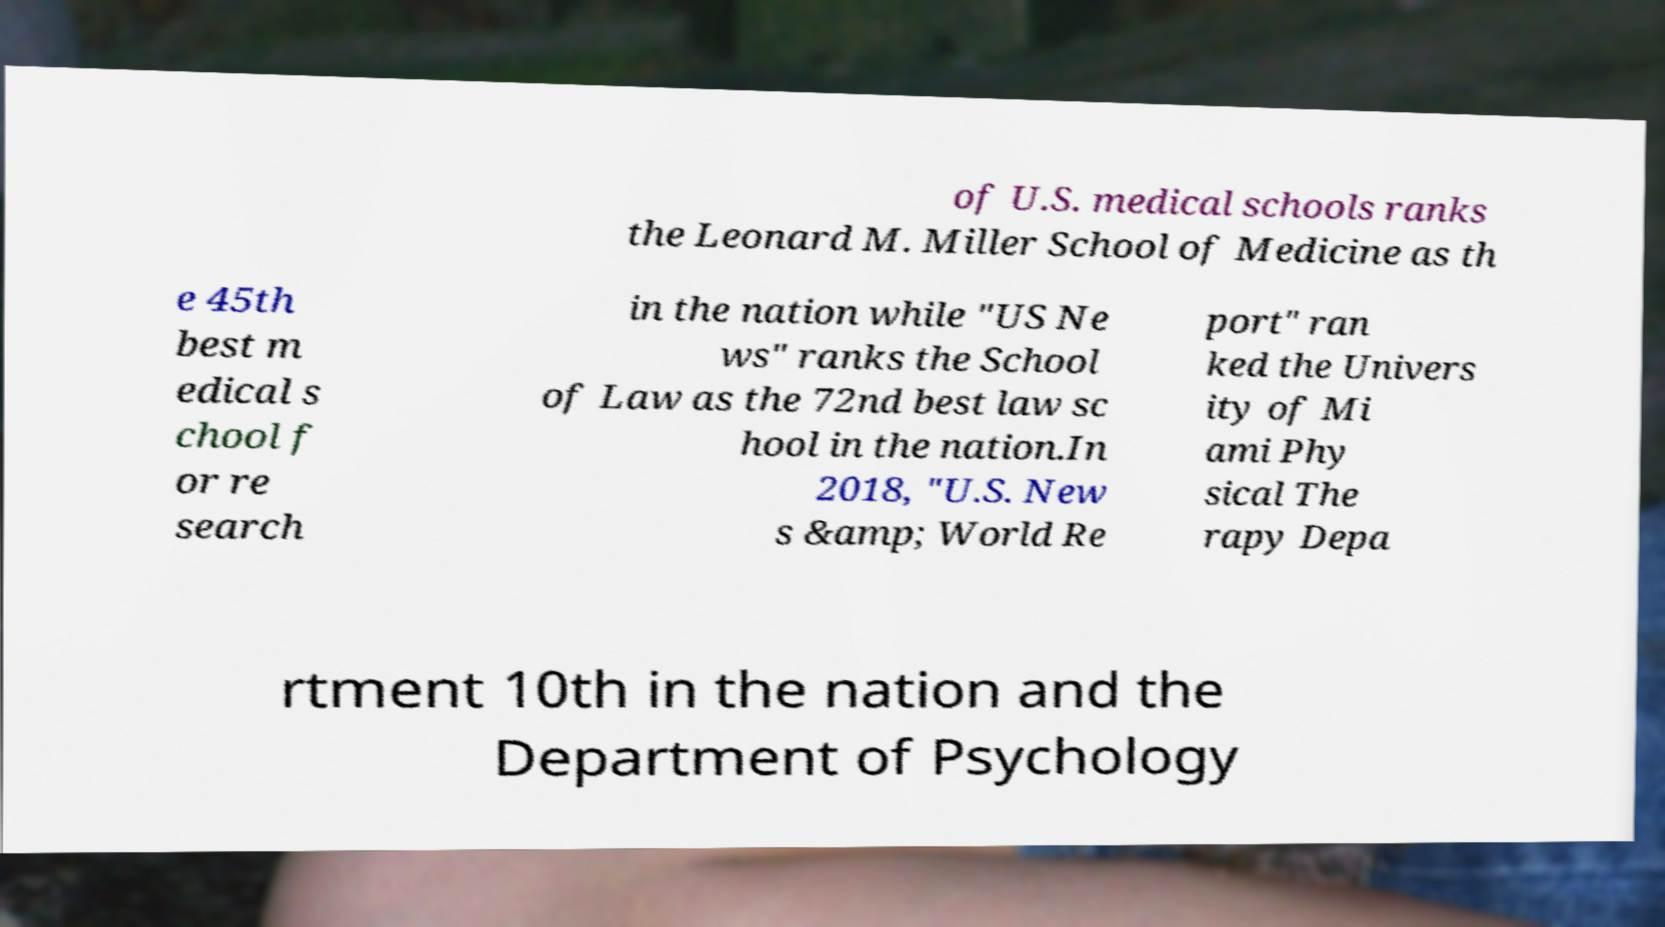Please read and relay the text visible in this image. What does it say? of U.S. medical schools ranks the Leonard M. Miller School of Medicine as th e 45th best m edical s chool f or re search in the nation while "US Ne ws" ranks the School of Law as the 72nd best law sc hool in the nation.In 2018, "U.S. New s &amp; World Re port" ran ked the Univers ity of Mi ami Phy sical The rapy Depa rtment 10th in the nation and the Department of Psychology 